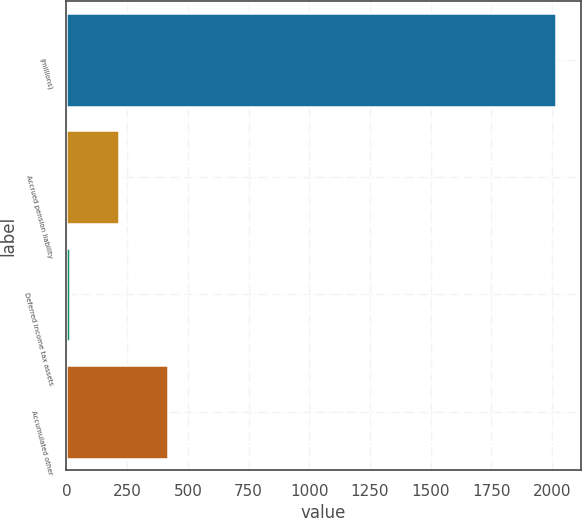Convert chart to OTSL. <chart><loc_0><loc_0><loc_500><loc_500><bar_chart><fcel>(millions)<fcel>Accrued pension liability<fcel>Deferred income tax assets<fcel>Accumulated other<nl><fcel>2016<fcel>216.81<fcel>16.9<fcel>416.72<nl></chart> 